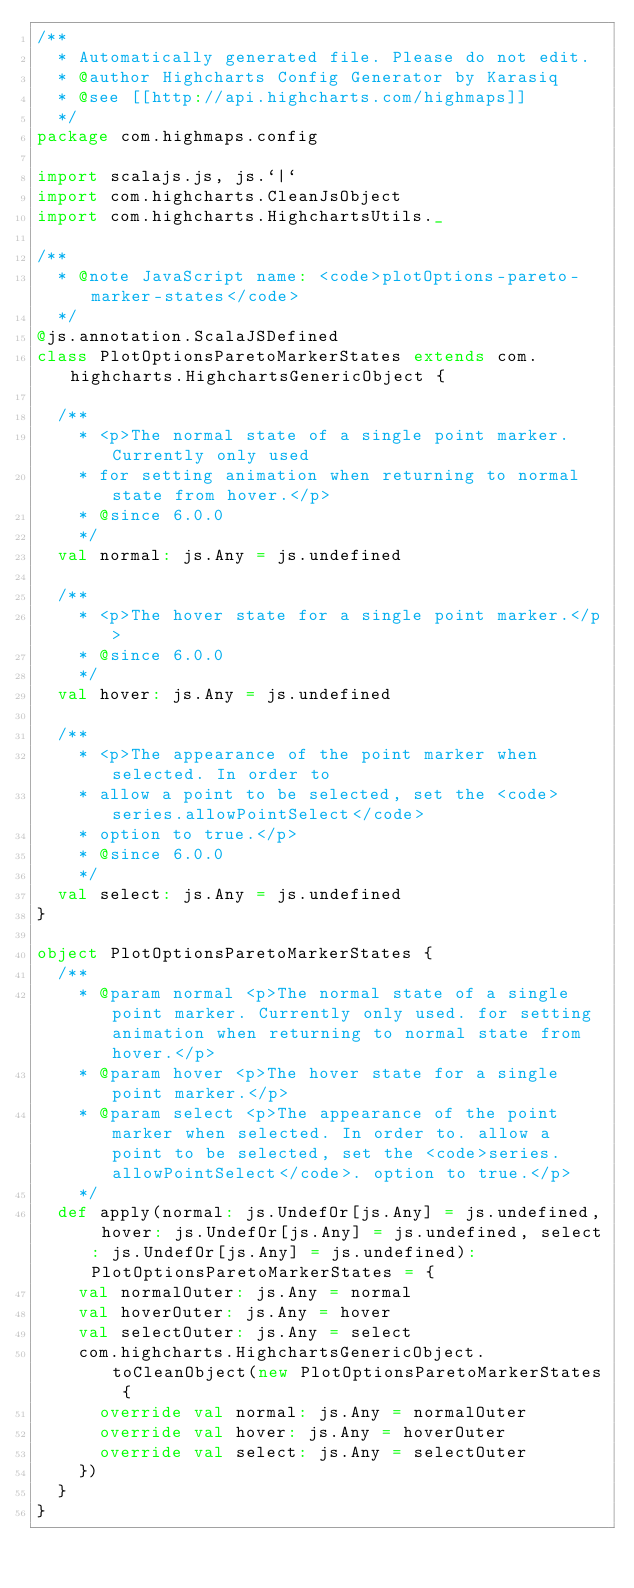Convert code to text. <code><loc_0><loc_0><loc_500><loc_500><_Scala_>/**
  * Automatically generated file. Please do not edit.
  * @author Highcharts Config Generator by Karasiq
  * @see [[http://api.highcharts.com/highmaps]]
  */
package com.highmaps.config

import scalajs.js, js.`|`
import com.highcharts.CleanJsObject
import com.highcharts.HighchartsUtils._

/**
  * @note JavaScript name: <code>plotOptions-pareto-marker-states</code>
  */
@js.annotation.ScalaJSDefined
class PlotOptionsParetoMarkerStates extends com.highcharts.HighchartsGenericObject {

  /**
    * <p>The normal state of a single point marker. Currently only used
    * for setting animation when returning to normal state from hover.</p>
    * @since 6.0.0
    */
  val normal: js.Any = js.undefined

  /**
    * <p>The hover state for a single point marker.</p>
    * @since 6.0.0
    */
  val hover: js.Any = js.undefined

  /**
    * <p>The appearance of the point marker when selected. In order to
    * allow a point to be selected, set the <code>series.allowPointSelect</code>
    * option to true.</p>
    * @since 6.0.0
    */
  val select: js.Any = js.undefined
}

object PlotOptionsParetoMarkerStates {
  /**
    * @param normal <p>The normal state of a single point marker. Currently only used. for setting animation when returning to normal state from hover.</p>
    * @param hover <p>The hover state for a single point marker.</p>
    * @param select <p>The appearance of the point marker when selected. In order to. allow a point to be selected, set the <code>series.allowPointSelect</code>. option to true.</p>
    */
  def apply(normal: js.UndefOr[js.Any] = js.undefined, hover: js.UndefOr[js.Any] = js.undefined, select: js.UndefOr[js.Any] = js.undefined): PlotOptionsParetoMarkerStates = {
    val normalOuter: js.Any = normal
    val hoverOuter: js.Any = hover
    val selectOuter: js.Any = select
    com.highcharts.HighchartsGenericObject.toCleanObject(new PlotOptionsParetoMarkerStates {
      override val normal: js.Any = normalOuter
      override val hover: js.Any = hoverOuter
      override val select: js.Any = selectOuter
    })
  }
}
</code> 